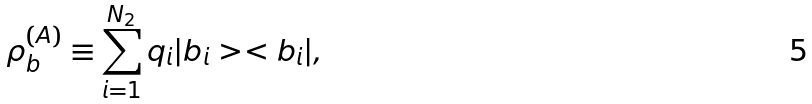Convert formula to latex. <formula><loc_0><loc_0><loc_500><loc_500>\rho ^ { ( A ) } _ { b } \equiv \sum _ { i = 1 } ^ { N _ { 2 } } q _ { i } | b _ { i } > < b _ { i } | ,</formula> 